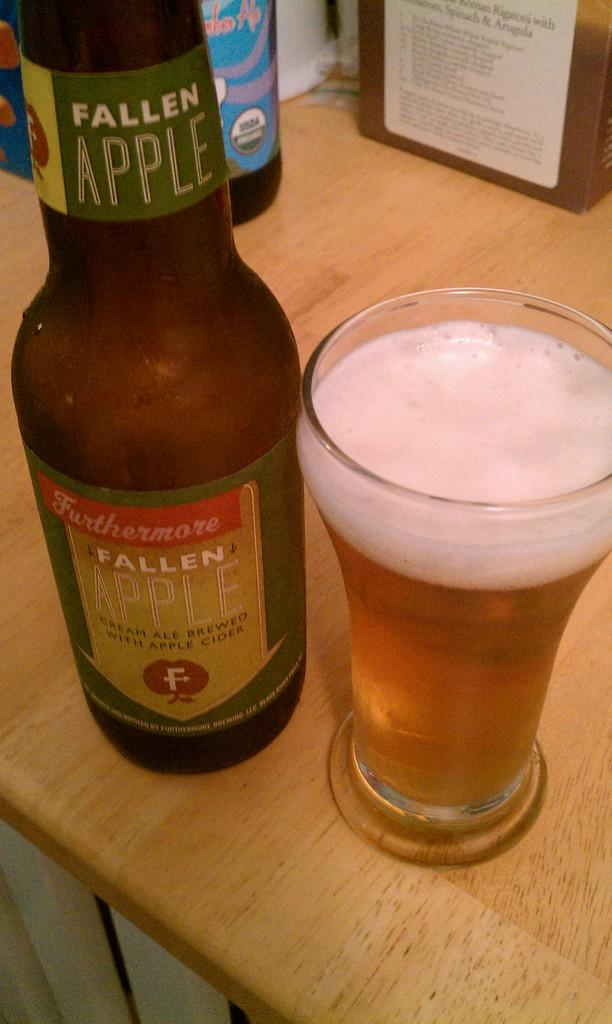<image>
Provide a brief description of the given image. a bottle of fallen apple cider next to a glass of it 